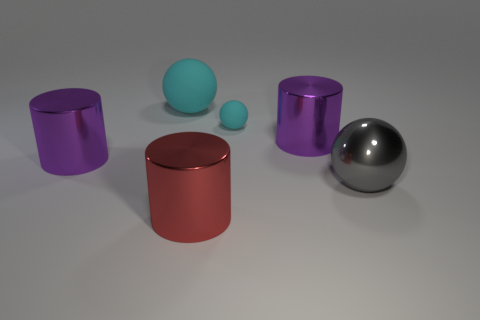Subtract all red spheres. How many purple cylinders are left? 2 Subtract all matte balls. How many balls are left? 1 Add 3 small purple matte objects. How many objects exist? 9 Subtract all big red shiny things. Subtract all cyan matte objects. How many objects are left? 3 Add 3 large gray shiny objects. How many large gray shiny objects are left? 4 Add 5 gray matte cylinders. How many gray matte cylinders exist? 5 Subtract 1 red cylinders. How many objects are left? 5 Subtract all blue cylinders. Subtract all gray spheres. How many cylinders are left? 3 